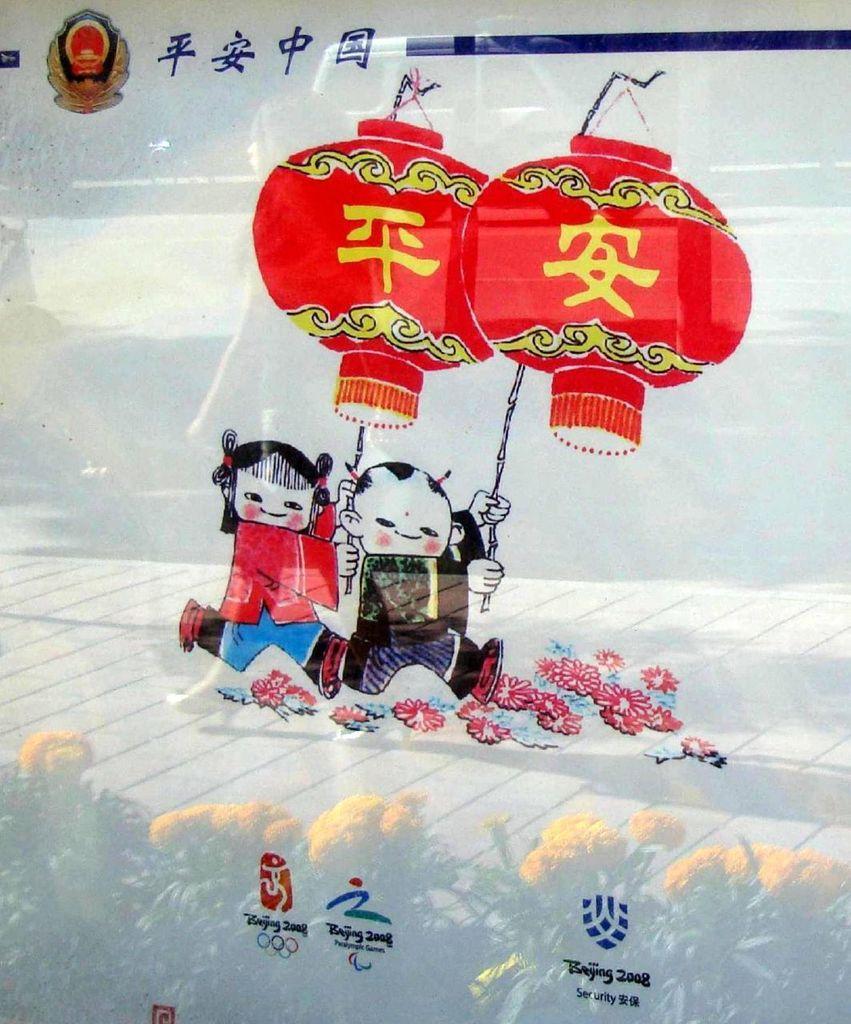Could you give a brief overview of what you see in this image? In the image,on a glass there is some painting is done and on the glass the pictures of a vehicle,two people and a platform and some beautiful plants with flowers are being reflected. 